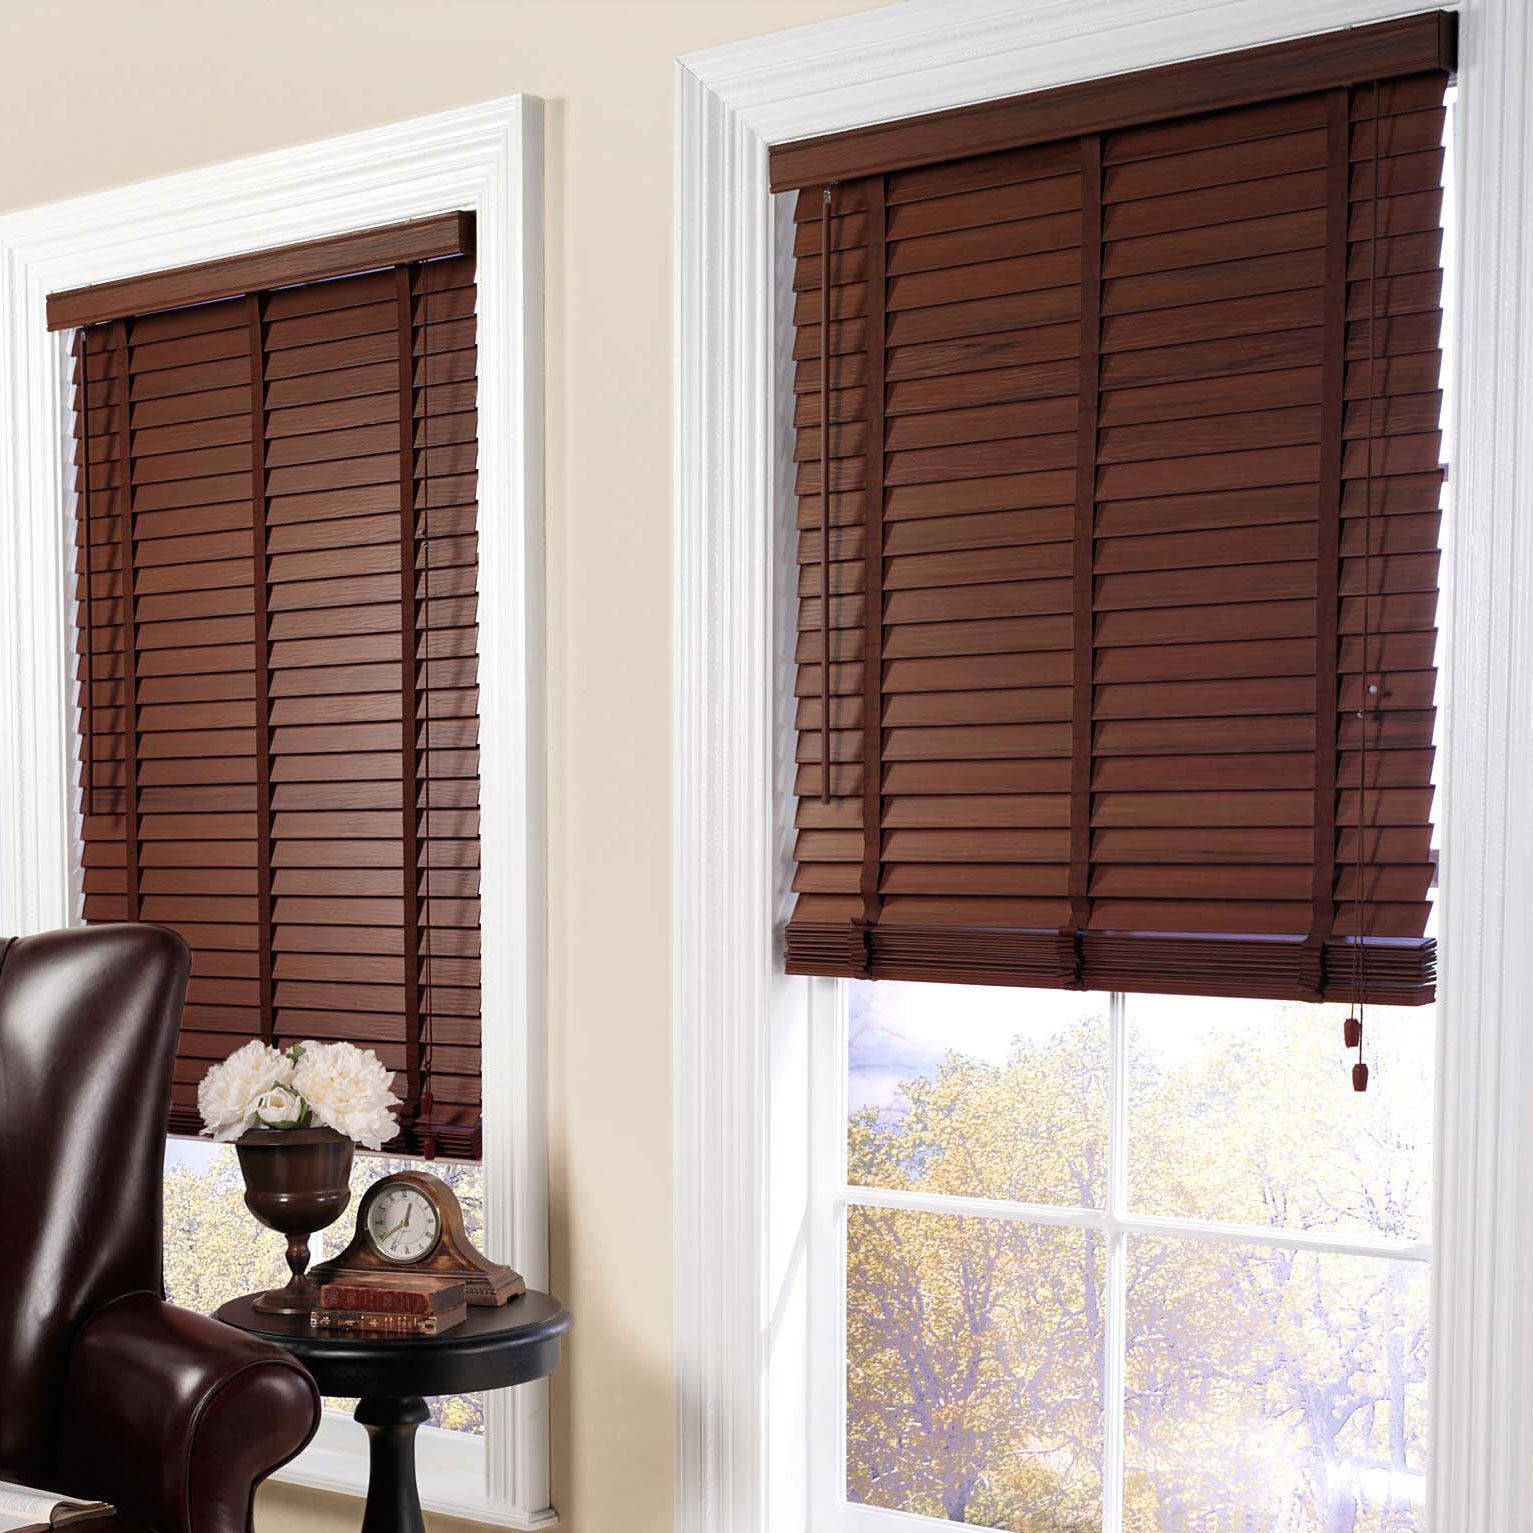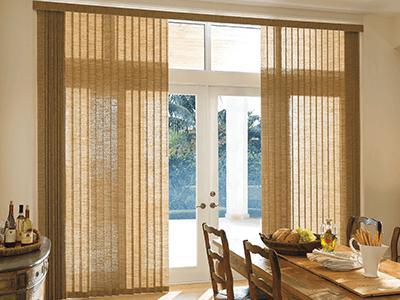The first image is the image on the left, the second image is the image on the right. Evaluate the accuracy of this statement regarding the images: "The left and right image contains a total of six blinds.". Is it true? Answer yes or no. No. The first image is the image on the left, the second image is the image on the right. Evaluate the accuracy of this statement regarding the images: "there are three windows with white trim and a sofa with pillows in front of it". Is it true? Answer yes or no. No. 